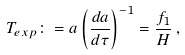Convert formula to latex. <formula><loc_0><loc_0><loc_500><loc_500>T _ { e x p } \colon = a \left ( \frac { d a } { d \tau } \right ) ^ { - 1 } = \frac { f _ { 1 } } { H } \, ,</formula> 